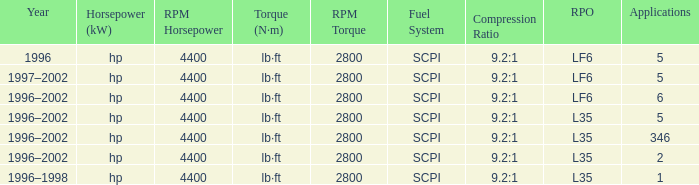What are the torque characteristics of the model made in 1996? Lb·ft (n·m) at 2,800rpm. 